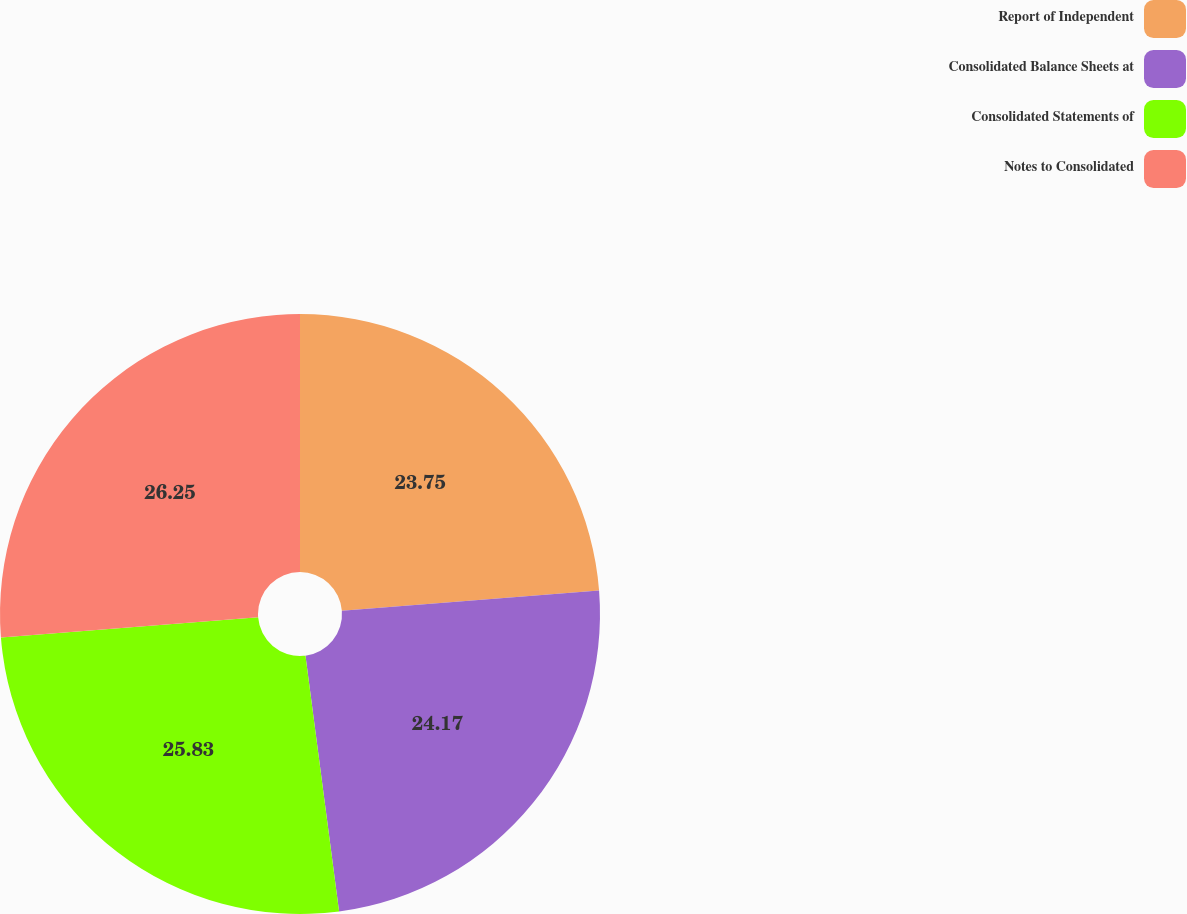Convert chart. <chart><loc_0><loc_0><loc_500><loc_500><pie_chart><fcel>Report of Independent<fcel>Consolidated Balance Sheets at<fcel>Consolidated Statements of<fcel>Notes to Consolidated<nl><fcel>23.75%<fcel>24.17%<fcel>25.83%<fcel>26.25%<nl></chart> 